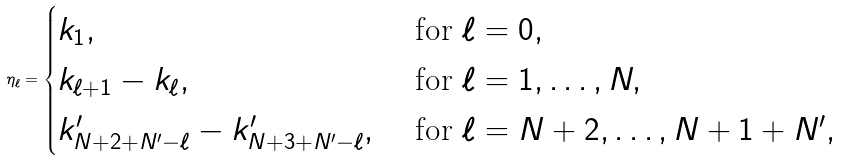Convert formula to latex. <formula><loc_0><loc_0><loc_500><loc_500>\eta _ { \ell } = \begin{cases} k _ { 1 } , & \text { for } \ell = 0 , \\ k _ { \ell + 1 } - k _ { \ell } , & \text { for } \ell = 1 , \dots , N , \\ k ^ { \prime } _ { N + 2 + N ^ { \prime } - \ell } - k ^ { \prime } _ { N + 3 + N ^ { \prime } - \ell } , & \text { for } \ell = N + 2 , \dots , N + 1 + N ^ { \prime } , \\ \end{cases}</formula> 